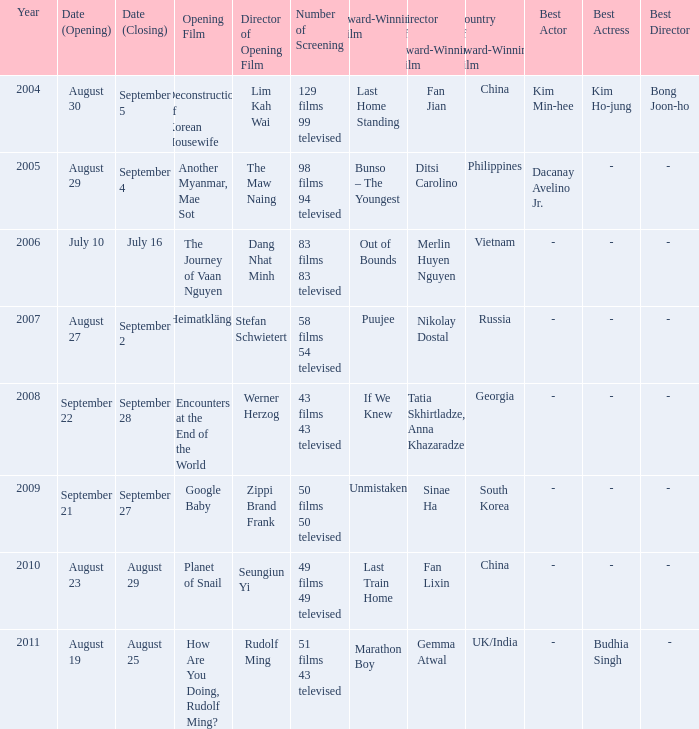Could you parse the entire table as a dict? {'header': ['Year', 'Date (Opening)', 'Date (Closing)', 'Opening Film', 'Director of Opening Film', 'Number of Screening', 'Award-Winning Film', 'Director of Award-Winning Film', 'Country of Award-Winning Film', 'Best Actor', 'Best Actress', 'Best Director'], 'rows': [['2004', 'August 30', 'September 5', 'Deconstruction of Korean Housewife', 'Lim Kah Wai', '129 films 99 televised', 'Last Home Standing', 'Fan Jian', 'China', 'Kim Min-hee', 'Kim Ho-jung', 'Bong Joon-ho'], ['2005', 'August 29', 'September 4', 'Another Myanmar, Mae Sot', 'The Maw Naing', '98 films 94 televised', 'Bunso – The Youngest', 'Ditsi Carolino', 'Philippines', 'Dacanay Avelino Jr.', '-', '- '], ['2006', 'July 10', 'July 16', 'The Journey of Vaan Nguyen', 'Dang Nhat Minh', '83 films 83 televised', 'Out of Bounds', 'Merlin Huyen Nguyen', 'Vietnam', '-', '-', '- '], ['2007', 'August 27', 'September 2', 'Heimatklänge', 'Stefan Schwietert', '58 films 54 televised', 'Puujee', 'Nikolay Dostal', 'Russia', '-', '-', '- '], ['2008', 'September 22', 'September 28', 'Encounters at the End of the World', 'Werner Herzog', '43 films 43 televised', 'If We Knew', 'Tatia Skhirtladze, Anna Khazaradze', 'Georgia', '-', '-', '- '], ['2009', 'September 21', 'September 27', 'Google Baby', 'Zippi Brand Frank', '50 films 50 televised', 'Unmistaken', 'Sinae Ha', 'South Korea', '-', '-', '- '], ['2010', 'August 23', 'August 29', 'Planet of Snail', 'Seungiun Yi', '49 films 49 televised', 'Last Train Home', 'Fan Lixin', 'China', '-', '-', '- '], ['2011', 'August 19', 'August 25', 'How Are You Doing, Rudolf Ming?', 'Rudolf Ming', '51 films 43 televised', 'Marathon Boy', 'Gemma Atwal', 'UK/India', '-', 'Budhia Singh', '-']]} Which award-winning film has a screening number of 50 films 50 televised? Unmistaken. 